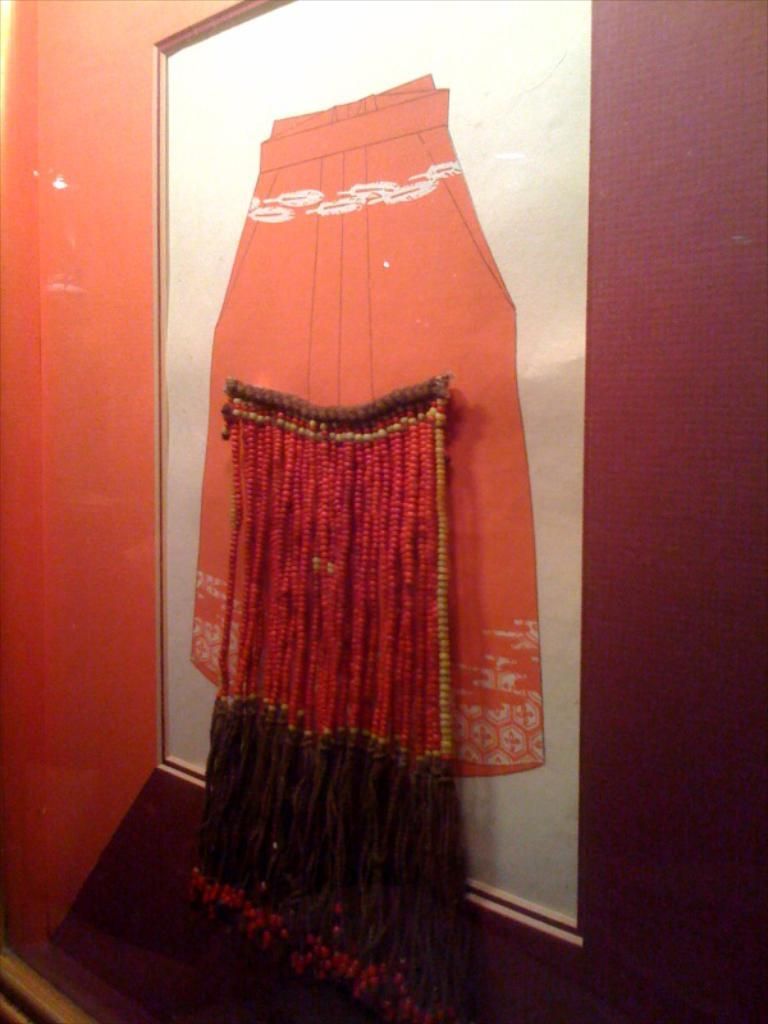What is present on the wall in the image? There is a poster on the wall. Are there any other items or objects attached to the wall? Yes, there are objects attached to the wall. What type of chalk drawings can be seen on the wall in the image? There are no chalk drawings present on the wall in the image. What kind of dust particles can be observed on the poster in the image? There is no mention of dust particles in the image, and therefore it cannot be determined if any are present. 